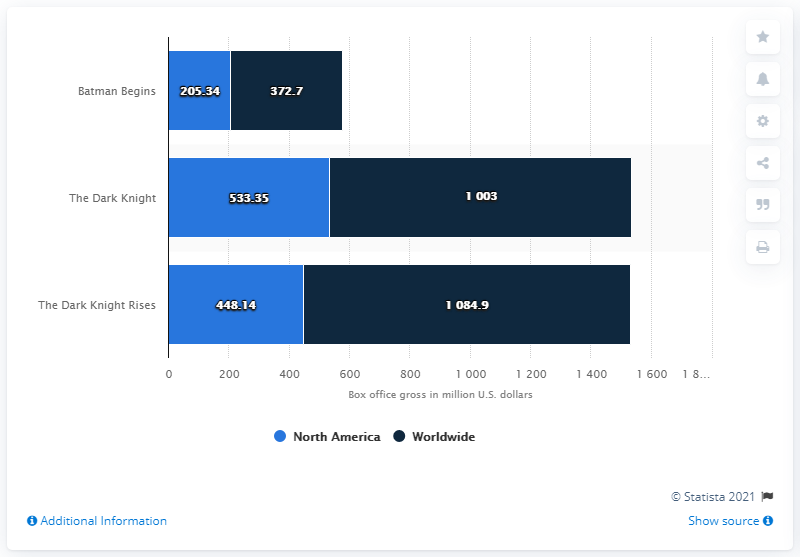Mention a couple of crucial points in this snapshot. The Dark Knight is the movie that generated the highest revenue in North America. In January 2017, the gross of The Dark Knight in North America was 533.35 million dollars. The total revenue for Dark Night was 1536.35. 